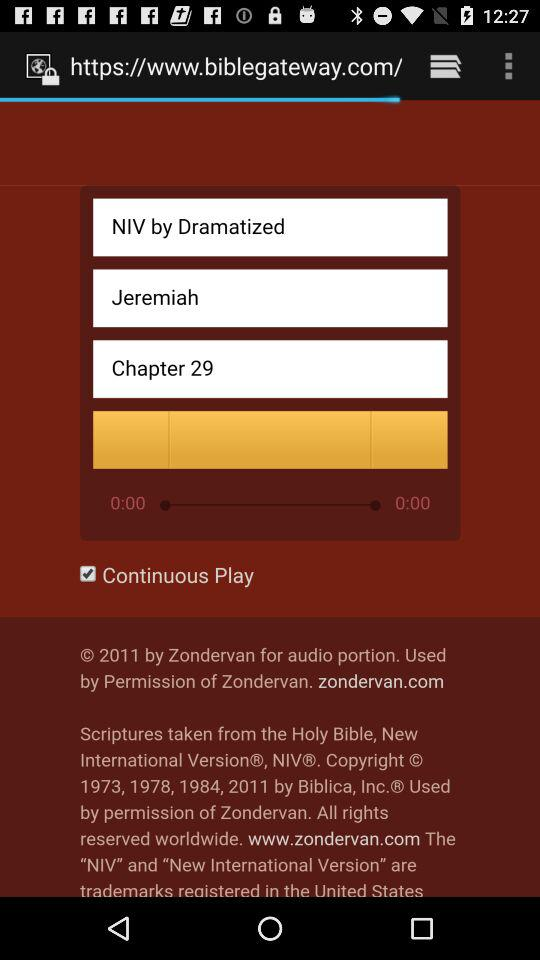What options are marked as checked? The option is "Continuous Play". 